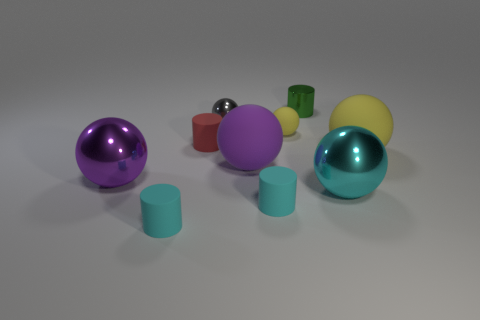Can you tell me which objects appear to have a matte finish, and which have a glossy look? Certainly. In this arrangement, there appears to be a mix of matte and glossy finishes among the objects. The small red cylinder and two teal cylinders exhibit a matte finish with no reflections. In contrast, the purple, teal, and yellow spheres, along with the small shiny red object, have a glossy surface that reflects the environment and highlights. 